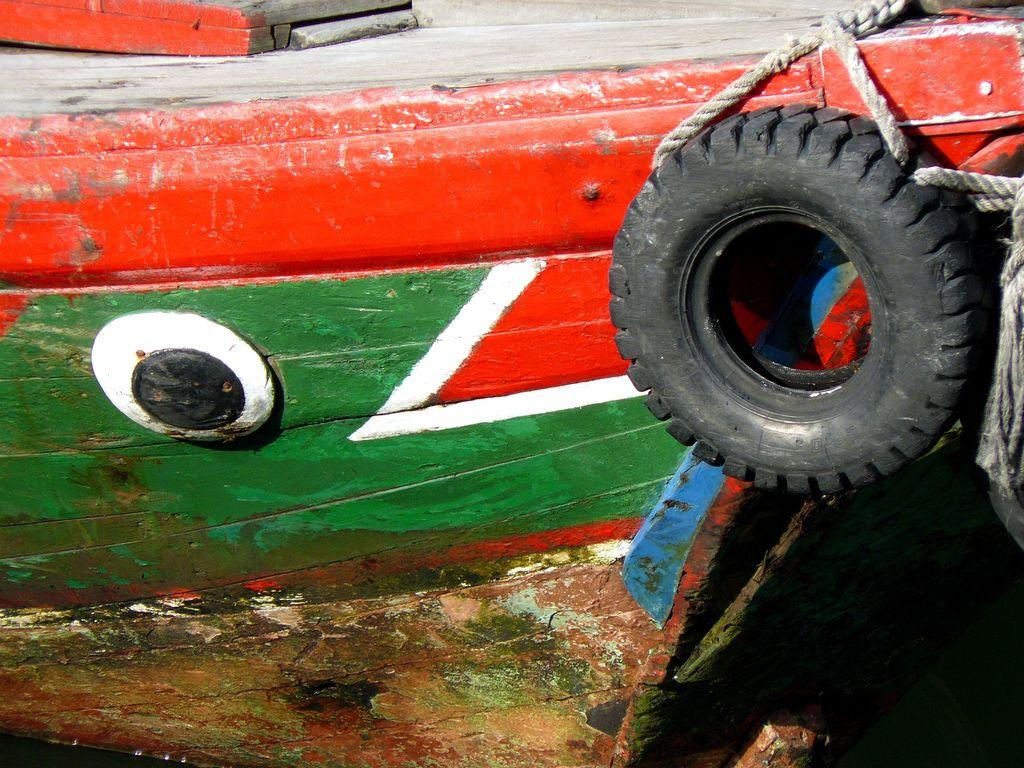What type of material is the wooden object made of in the image? The wooden object in the image is made of wood. What other object can be seen in the image? There is a tire in the image. What are the ropes used for in the image? The purpose of the ropes in the image is not explicitly stated, but they may be used for tying or securing objects. How many chickens are present in the image? There are no chickens present in the image. What type of zebra can be seen interacting with the tire in the image? There is no zebra present in the image, and therefore no such interaction can be observed. 